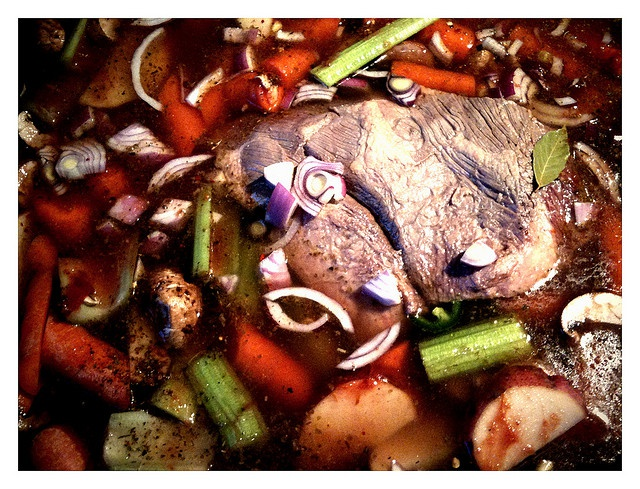Describe the objects in this image and their specific colors. I can see apple in white, maroon, orange, brown, and black tones, apple in white, tan, brown, and maroon tones, apple in white, maroon, black, and brown tones, carrot in white, brown, maroon, and red tones, and carrot in white, maroon, black, and brown tones in this image. 